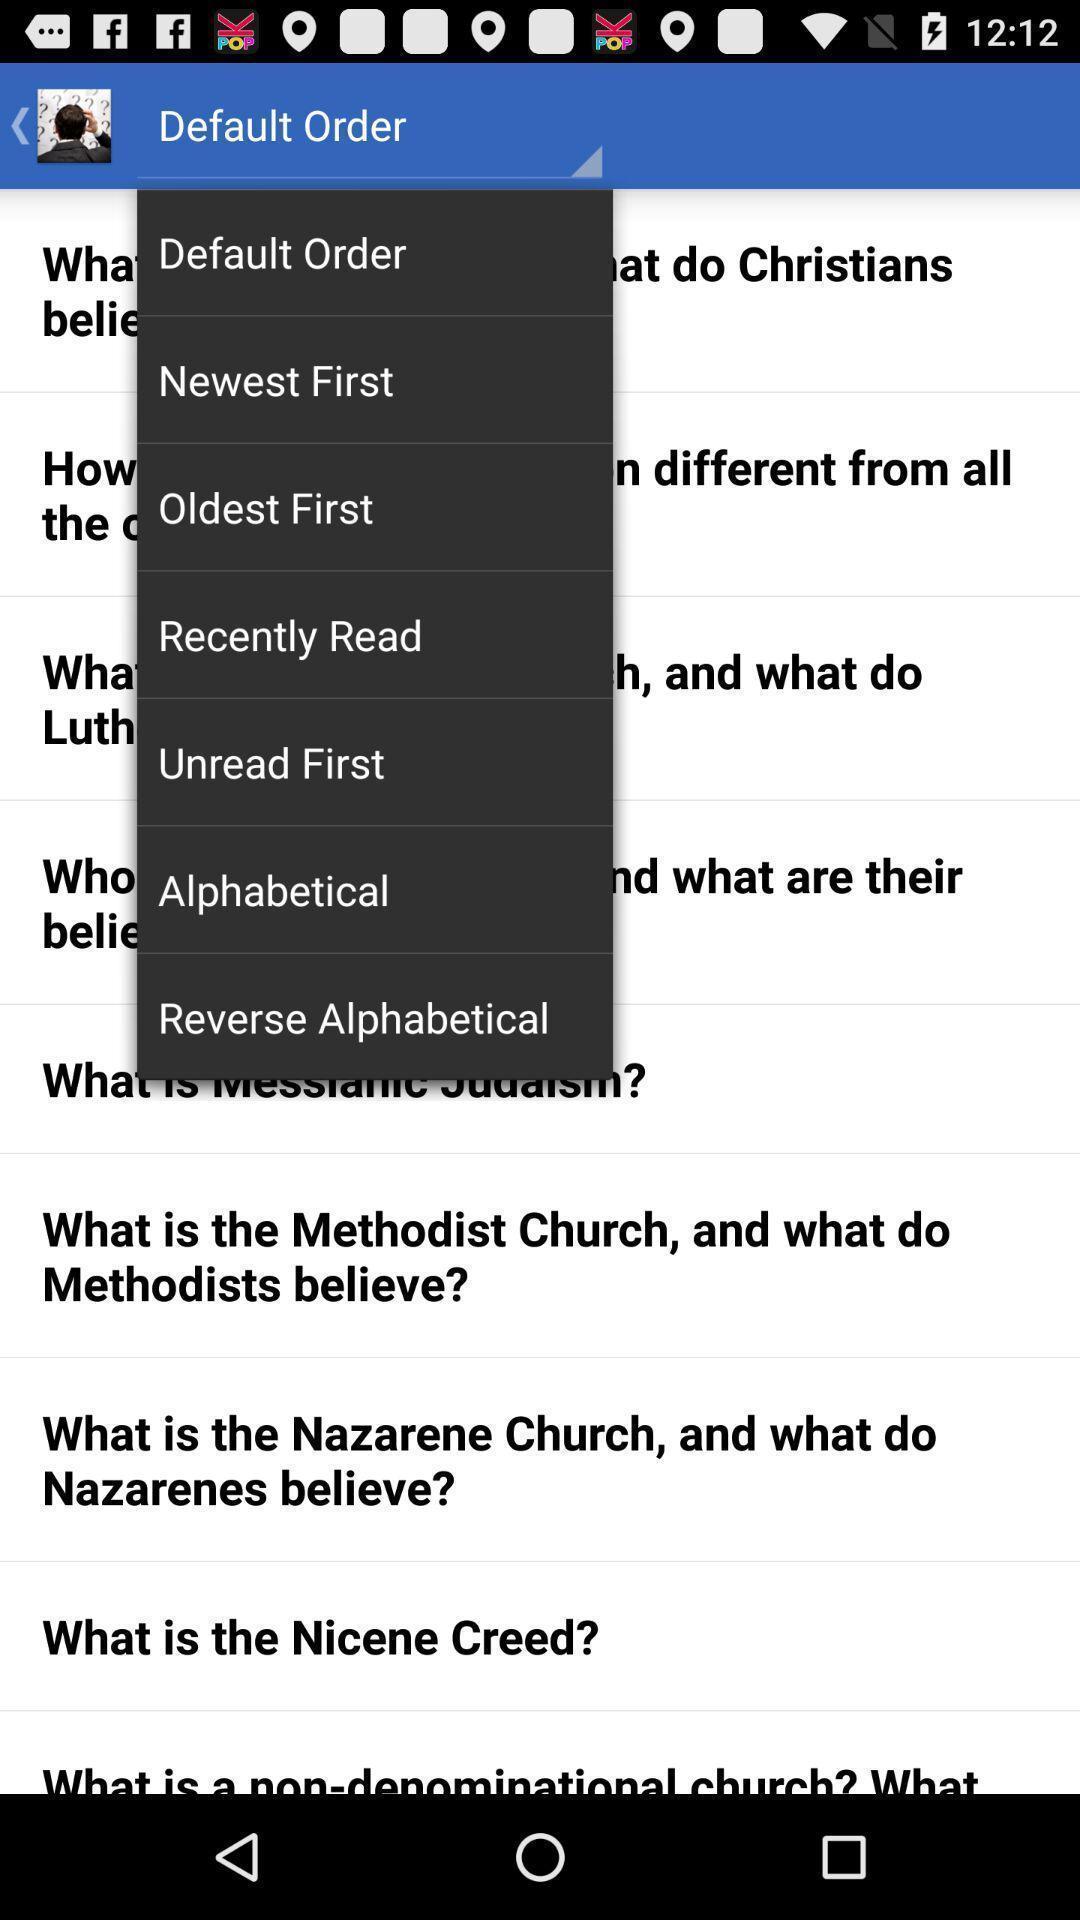Explain the elements present in this screenshot. Screen showing with options. 